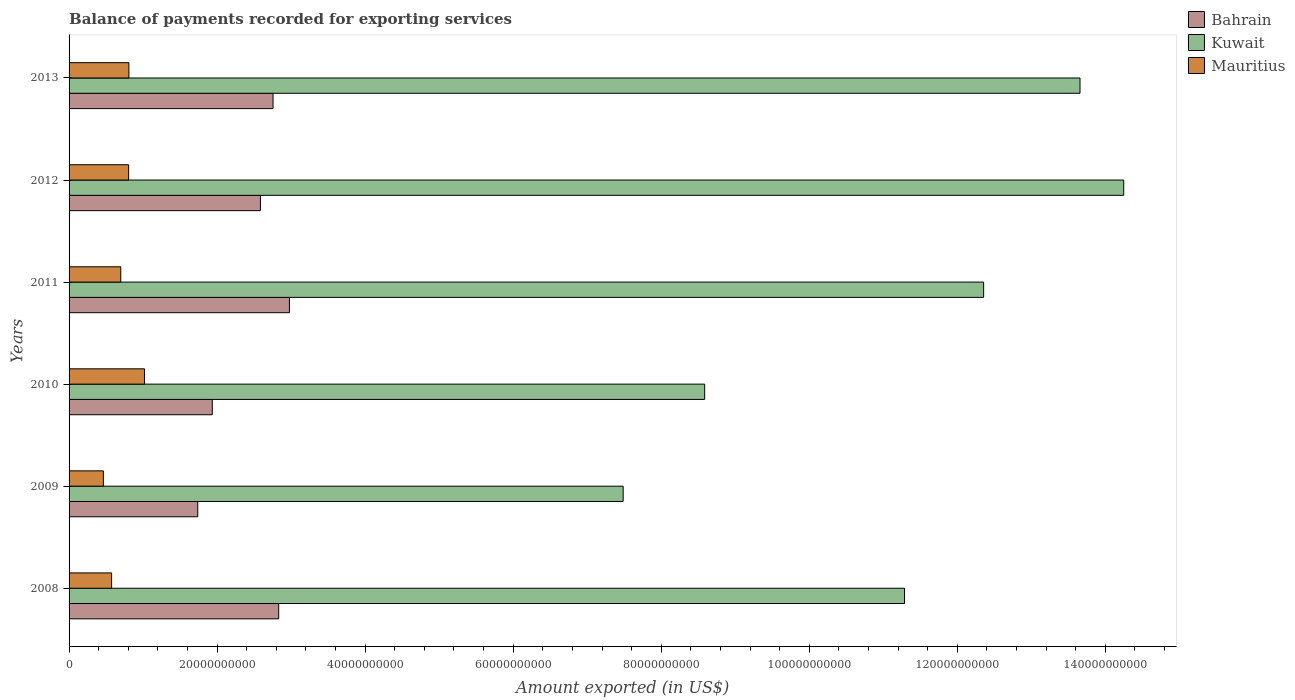How many groups of bars are there?
Keep it short and to the point. 6. How many bars are there on the 6th tick from the top?
Your answer should be very brief. 3. In how many cases, is the number of bars for a given year not equal to the number of legend labels?
Offer a very short reply. 0. What is the amount exported in Bahrain in 2008?
Your answer should be very brief. 2.83e+1. Across all years, what is the maximum amount exported in Bahrain?
Provide a short and direct response. 2.98e+1. Across all years, what is the minimum amount exported in Bahrain?
Ensure brevity in your answer.  1.74e+1. In which year was the amount exported in Kuwait maximum?
Your response must be concise. 2012. What is the total amount exported in Kuwait in the graph?
Make the answer very short. 6.76e+11. What is the difference between the amount exported in Mauritius in 2008 and that in 2013?
Provide a succinct answer. -2.33e+09. What is the difference between the amount exported in Kuwait in 2009 and the amount exported in Mauritius in 2011?
Your response must be concise. 6.79e+1. What is the average amount exported in Mauritius per year?
Offer a terse response. 7.28e+09. In the year 2010, what is the difference between the amount exported in Kuwait and amount exported in Bahrain?
Offer a very short reply. 6.65e+1. What is the ratio of the amount exported in Kuwait in 2008 to that in 2013?
Your response must be concise. 0.83. Is the difference between the amount exported in Kuwait in 2009 and 2010 greater than the difference between the amount exported in Bahrain in 2009 and 2010?
Keep it short and to the point. No. What is the difference between the highest and the second highest amount exported in Mauritius?
Ensure brevity in your answer.  2.11e+09. What is the difference between the highest and the lowest amount exported in Bahrain?
Keep it short and to the point. 1.24e+1. In how many years, is the amount exported in Mauritius greater than the average amount exported in Mauritius taken over all years?
Offer a terse response. 3. Is the sum of the amount exported in Bahrain in 2011 and 2013 greater than the maximum amount exported in Kuwait across all years?
Your answer should be very brief. No. What does the 3rd bar from the top in 2012 represents?
Keep it short and to the point. Bahrain. What does the 2nd bar from the bottom in 2012 represents?
Provide a short and direct response. Kuwait. How many bars are there?
Provide a short and direct response. 18. How many years are there in the graph?
Keep it short and to the point. 6. Are the values on the major ticks of X-axis written in scientific E-notation?
Ensure brevity in your answer.  No. Does the graph contain grids?
Give a very brief answer. No. How are the legend labels stacked?
Provide a short and direct response. Vertical. What is the title of the graph?
Provide a succinct answer. Balance of payments recorded for exporting services. Does "San Marino" appear as one of the legend labels in the graph?
Ensure brevity in your answer.  No. What is the label or title of the X-axis?
Provide a succinct answer. Amount exported (in US$). What is the label or title of the Y-axis?
Provide a short and direct response. Years. What is the Amount exported (in US$) in Bahrain in 2008?
Offer a terse response. 2.83e+1. What is the Amount exported (in US$) of Kuwait in 2008?
Your answer should be very brief. 1.13e+11. What is the Amount exported (in US$) in Mauritius in 2008?
Make the answer very short. 5.75e+09. What is the Amount exported (in US$) of Bahrain in 2009?
Give a very brief answer. 1.74e+1. What is the Amount exported (in US$) of Kuwait in 2009?
Offer a very short reply. 7.49e+1. What is the Amount exported (in US$) of Mauritius in 2009?
Ensure brevity in your answer.  4.64e+09. What is the Amount exported (in US$) in Bahrain in 2010?
Your answer should be compact. 1.93e+1. What is the Amount exported (in US$) in Kuwait in 2010?
Keep it short and to the point. 8.59e+1. What is the Amount exported (in US$) in Mauritius in 2010?
Your answer should be compact. 1.02e+1. What is the Amount exported (in US$) in Bahrain in 2011?
Give a very brief answer. 2.98e+1. What is the Amount exported (in US$) in Kuwait in 2011?
Your answer should be compact. 1.24e+11. What is the Amount exported (in US$) in Mauritius in 2011?
Keep it short and to the point. 6.98e+09. What is the Amount exported (in US$) of Bahrain in 2012?
Keep it short and to the point. 2.59e+1. What is the Amount exported (in US$) of Kuwait in 2012?
Your answer should be very brief. 1.42e+11. What is the Amount exported (in US$) of Mauritius in 2012?
Keep it short and to the point. 8.05e+09. What is the Amount exported (in US$) in Bahrain in 2013?
Offer a terse response. 2.76e+1. What is the Amount exported (in US$) in Kuwait in 2013?
Give a very brief answer. 1.37e+11. What is the Amount exported (in US$) of Mauritius in 2013?
Your answer should be very brief. 8.08e+09. Across all years, what is the maximum Amount exported (in US$) of Bahrain?
Provide a succinct answer. 2.98e+1. Across all years, what is the maximum Amount exported (in US$) of Kuwait?
Ensure brevity in your answer.  1.42e+11. Across all years, what is the maximum Amount exported (in US$) in Mauritius?
Provide a succinct answer. 1.02e+1. Across all years, what is the minimum Amount exported (in US$) of Bahrain?
Your response must be concise. 1.74e+1. Across all years, what is the minimum Amount exported (in US$) of Kuwait?
Your response must be concise. 7.49e+1. Across all years, what is the minimum Amount exported (in US$) of Mauritius?
Your response must be concise. 4.64e+09. What is the total Amount exported (in US$) of Bahrain in the graph?
Provide a short and direct response. 1.48e+11. What is the total Amount exported (in US$) of Kuwait in the graph?
Keep it short and to the point. 6.76e+11. What is the total Amount exported (in US$) in Mauritius in the graph?
Keep it short and to the point. 4.37e+1. What is the difference between the Amount exported (in US$) of Bahrain in 2008 and that in 2009?
Your answer should be very brief. 1.09e+1. What is the difference between the Amount exported (in US$) in Kuwait in 2008 and that in 2009?
Your response must be concise. 3.80e+1. What is the difference between the Amount exported (in US$) of Mauritius in 2008 and that in 2009?
Your answer should be very brief. 1.11e+09. What is the difference between the Amount exported (in US$) in Bahrain in 2008 and that in 2010?
Your response must be concise. 8.97e+09. What is the difference between the Amount exported (in US$) of Kuwait in 2008 and that in 2010?
Make the answer very short. 2.70e+1. What is the difference between the Amount exported (in US$) of Mauritius in 2008 and that in 2010?
Your response must be concise. -4.44e+09. What is the difference between the Amount exported (in US$) in Bahrain in 2008 and that in 2011?
Provide a succinct answer. -1.45e+09. What is the difference between the Amount exported (in US$) of Kuwait in 2008 and that in 2011?
Provide a succinct answer. -1.07e+1. What is the difference between the Amount exported (in US$) in Mauritius in 2008 and that in 2011?
Provide a short and direct response. -1.24e+09. What is the difference between the Amount exported (in US$) in Bahrain in 2008 and that in 2012?
Provide a short and direct response. 2.47e+09. What is the difference between the Amount exported (in US$) in Kuwait in 2008 and that in 2012?
Offer a very short reply. -2.96e+1. What is the difference between the Amount exported (in US$) in Mauritius in 2008 and that in 2012?
Offer a terse response. -2.30e+09. What is the difference between the Amount exported (in US$) in Bahrain in 2008 and that in 2013?
Offer a terse response. 7.64e+08. What is the difference between the Amount exported (in US$) in Kuwait in 2008 and that in 2013?
Keep it short and to the point. -2.37e+1. What is the difference between the Amount exported (in US$) of Mauritius in 2008 and that in 2013?
Ensure brevity in your answer.  -2.33e+09. What is the difference between the Amount exported (in US$) of Bahrain in 2009 and that in 2010?
Keep it short and to the point. -1.96e+09. What is the difference between the Amount exported (in US$) in Kuwait in 2009 and that in 2010?
Provide a succinct answer. -1.10e+1. What is the difference between the Amount exported (in US$) in Mauritius in 2009 and that in 2010?
Give a very brief answer. -5.55e+09. What is the difference between the Amount exported (in US$) of Bahrain in 2009 and that in 2011?
Make the answer very short. -1.24e+1. What is the difference between the Amount exported (in US$) of Kuwait in 2009 and that in 2011?
Make the answer very short. -4.87e+1. What is the difference between the Amount exported (in US$) of Mauritius in 2009 and that in 2011?
Keep it short and to the point. -2.35e+09. What is the difference between the Amount exported (in US$) in Bahrain in 2009 and that in 2012?
Your answer should be compact. -8.47e+09. What is the difference between the Amount exported (in US$) in Kuwait in 2009 and that in 2012?
Ensure brevity in your answer.  -6.76e+1. What is the difference between the Amount exported (in US$) in Mauritius in 2009 and that in 2012?
Provide a short and direct response. -3.41e+09. What is the difference between the Amount exported (in US$) of Bahrain in 2009 and that in 2013?
Your answer should be very brief. -1.02e+1. What is the difference between the Amount exported (in US$) in Kuwait in 2009 and that in 2013?
Provide a succinct answer. -6.17e+1. What is the difference between the Amount exported (in US$) of Mauritius in 2009 and that in 2013?
Provide a short and direct response. -3.45e+09. What is the difference between the Amount exported (in US$) in Bahrain in 2010 and that in 2011?
Give a very brief answer. -1.04e+1. What is the difference between the Amount exported (in US$) in Kuwait in 2010 and that in 2011?
Provide a succinct answer. -3.77e+1. What is the difference between the Amount exported (in US$) in Mauritius in 2010 and that in 2011?
Provide a succinct answer. 3.21e+09. What is the difference between the Amount exported (in US$) in Bahrain in 2010 and that in 2012?
Make the answer very short. -6.50e+09. What is the difference between the Amount exported (in US$) of Kuwait in 2010 and that in 2012?
Your response must be concise. -5.66e+1. What is the difference between the Amount exported (in US$) of Mauritius in 2010 and that in 2012?
Keep it short and to the point. 2.14e+09. What is the difference between the Amount exported (in US$) of Bahrain in 2010 and that in 2013?
Offer a very short reply. -8.21e+09. What is the difference between the Amount exported (in US$) of Kuwait in 2010 and that in 2013?
Give a very brief answer. -5.07e+1. What is the difference between the Amount exported (in US$) in Mauritius in 2010 and that in 2013?
Your answer should be very brief. 2.11e+09. What is the difference between the Amount exported (in US$) of Bahrain in 2011 and that in 2012?
Ensure brevity in your answer.  3.92e+09. What is the difference between the Amount exported (in US$) in Kuwait in 2011 and that in 2012?
Give a very brief answer. -1.89e+1. What is the difference between the Amount exported (in US$) of Mauritius in 2011 and that in 2012?
Provide a succinct answer. -1.06e+09. What is the difference between the Amount exported (in US$) of Bahrain in 2011 and that in 2013?
Make the answer very short. 2.21e+09. What is the difference between the Amount exported (in US$) in Kuwait in 2011 and that in 2013?
Make the answer very short. -1.30e+1. What is the difference between the Amount exported (in US$) in Mauritius in 2011 and that in 2013?
Make the answer very short. -1.10e+09. What is the difference between the Amount exported (in US$) of Bahrain in 2012 and that in 2013?
Keep it short and to the point. -1.70e+09. What is the difference between the Amount exported (in US$) of Kuwait in 2012 and that in 2013?
Make the answer very short. 5.90e+09. What is the difference between the Amount exported (in US$) in Mauritius in 2012 and that in 2013?
Ensure brevity in your answer.  -3.39e+07. What is the difference between the Amount exported (in US$) of Bahrain in 2008 and the Amount exported (in US$) of Kuwait in 2009?
Give a very brief answer. -4.65e+1. What is the difference between the Amount exported (in US$) in Bahrain in 2008 and the Amount exported (in US$) in Mauritius in 2009?
Offer a very short reply. 2.37e+1. What is the difference between the Amount exported (in US$) in Kuwait in 2008 and the Amount exported (in US$) in Mauritius in 2009?
Offer a terse response. 1.08e+11. What is the difference between the Amount exported (in US$) in Bahrain in 2008 and the Amount exported (in US$) in Kuwait in 2010?
Keep it short and to the point. -5.75e+1. What is the difference between the Amount exported (in US$) in Bahrain in 2008 and the Amount exported (in US$) in Mauritius in 2010?
Your response must be concise. 1.81e+1. What is the difference between the Amount exported (in US$) of Kuwait in 2008 and the Amount exported (in US$) of Mauritius in 2010?
Provide a short and direct response. 1.03e+11. What is the difference between the Amount exported (in US$) of Bahrain in 2008 and the Amount exported (in US$) of Kuwait in 2011?
Ensure brevity in your answer.  -9.52e+1. What is the difference between the Amount exported (in US$) in Bahrain in 2008 and the Amount exported (in US$) in Mauritius in 2011?
Provide a short and direct response. 2.13e+1. What is the difference between the Amount exported (in US$) in Kuwait in 2008 and the Amount exported (in US$) in Mauritius in 2011?
Provide a short and direct response. 1.06e+11. What is the difference between the Amount exported (in US$) in Bahrain in 2008 and the Amount exported (in US$) in Kuwait in 2012?
Make the answer very short. -1.14e+11. What is the difference between the Amount exported (in US$) of Bahrain in 2008 and the Amount exported (in US$) of Mauritius in 2012?
Your answer should be very brief. 2.03e+1. What is the difference between the Amount exported (in US$) in Kuwait in 2008 and the Amount exported (in US$) in Mauritius in 2012?
Ensure brevity in your answer.  1.05e+11. What is the difference between the Amount exported (in US$) in Bahrain in 2008 and the Amount exported (in US$) in Kuwait in 2013?
Give a very brief answer. -1.08e+11. What is the difference between the Amount exported (in US$) of Bahrain in 2008 and the Amount exported (in US$) of Mauritius in 2013?
Provide a succinct answer. 2.02e+1. What is the difference between the Amount exported (in US$) of Kuwait in 2008 and the Amount exported (in US$) of Mauritius in 2013?
Your answer should be very brief. 1.05e+11. What is the difference between the Amount exported (in US$) of Bahrain in 2009 and the Amount exported (in US$) of Kuwait in 2010?
Your answer should be very brief. -6.85e+1. What is the difference between the Amount exported (in US$) of Bahrain in 2009 and the Amount exported (in US$) of Mauritius in 2010?
Give a very brief answer. 7.20e+09. What is the difference between the Amount exported (in US$) of Kuwait in 2009 and the Amount exported (in US$) of Mauritius in 2010?
Ensure brevity in your answer.  6.47e+1. What is the difference between the Amount exported (in US$) of Bahrain in 2009 and the Amount exported (in US$) of Kuwait in 2011?
Your response must be concise. -1.06e+11. What is the difference between the Amount exported (in US$) of Bahrain in 2009 and the Amount exported (in US$) of Mauritius in 2011?
Give a very brief answer. 1.04e+1. What is the difference between the Amount exported (in US$) of Kuwait in 2009 and the Amount exported (in US$) of Mauritius in 2011?
Offer a terse response. 6.79e+1. What is the difference between the Amount exported (in US$) of Bahrain in 2009 and the Amount exported (in US$) of Kuwait in 2012?
Keep it short and to the point. -1.25e+11. What is the difference between the Amount exported (in US$) in Bahrain in 2009 and the Amount exported (in US$) in Mauritius in 2012?
Provide a short and direct response. 9.34e+09. What is the difference between the Amount exported (in US$) of Kuwait in 2009 and the Amount exported (in US$) of Mauritius in 2012?
Provide a succinct answer. 6.68e+1. What is the difference between the Amount exported (in US$) in Bahrain in 2009 and the Amount exported (in US$) in Kuwait in 2013?
Your response must be concise. -1.19e+11. What is the difference between the Amount exported (in US$) of Bahrain in 2009 and the Amount exported (in US$) of Mauritius in 2013?
Your answer should be very brief. 9.30e+09. What is the difference between the Amount exported (in US$) of Kuwait in 2009 and the Amount exported (in US$) of Mauritius in 2013?
Your answer should be very brief. 6.68e+1. What is the difference between the Amount exported (in US$) of Bahrain in 2010 and the Amount exported (in US$) of Kuwait in 2011?
Provide a short and direct response. -1.04e+11. What is the difference between the Amount exported (in US$) in Bahrain in 2010 and the Amount exported (in US$) in Mauritius in 2011?
Provide a succinct answer. 1.24e+1. What is the difference between the Amount exported (in US$) of Kuwait in 2010 and the Amount exported (in US$) of Mauritius in 2011?
Keep it short and to the point. 7.89e+1. What is the difference between the Amount exported (in US$) in Bahrain in 2010 and the Amount exported (in US$) in Kuwait in 2012?
Make the answer very short. -1.23e+11. What is the difference between the Amount exported (in US$) of Bahrain in 2010 and the Amount exported (in US$) of Mauritius in 2012?
Offer a very short reply. 1.13e+1. What is the difference between the Amount exported (in US$) in Kuwait in 2010 and the Amount exported (in US$) in Mauritius in 2012?
Provide a short and direct response. 7.78e+1. What is the difference between the Amount exported (in US$) of Bahrain in 2010 and the Amount exported (in US$) of Kuwait in 2013?
Your response must be concise. -1.17e+11. What is the difference between the Amount exported (in US$) of Bahrain in 2010 and the Amount exported (in US$) of Mauritius in 2013?
Your response must be concise. 1.13e+1. What is the difference between the Amount exported (in US$) in Kuwait in 2010 and the Amount exported (in US$) in Mauritius in 2013?
Your answer should be very brief. 7.78e+1. What is the difference between the Amount exported (in US$) in Bahrain in 2011 and the Amount exported (in US$) in Kuwait in 2012?
Give a very brief answer. -1.13e+11. What is the difference between the Amount exported (in US$) of Bahrain in 2011 and the Amount exported (in US$) of Mauritius in 2012?
Offer a terse response. 2.17e+1. What is the difference between the Amount exported (in US$) in Kuwait in 2011 and the Amount exported (in US$) in Mauritius in 2012?
Your answer should be very brief. 1.16e+11. What is the difference between the Amount exported (in US$) of Bahrain in 2011 and the Amount exported (in US$) of Kuwait in 2013?
Your answer should be very brief. -1.07e+11. What is the difference between the Amount exported (in US$) in Bahrain in 2011 and the Amount exported (in US$) in Mauritius in 2013?
Offer a very short reply. 2.17e+1. What is the difference between the Amount exported (in US$) in Kuwait in 2011 and the Amount exported (in US$) in Mauritius in 2013?
Offer a very short reply. 1.15e+11. What is the difference between the Amount exported (in US$) of Bahrain in 2012 and the Amount exported (in US$) of Kuwait in 2013?
Offer a terse response. -1.11e+11. What is the difference between the Amount exported (in US$) of Bahrain in 2012 and the Amount exported (in US$) of Mauritius in 2013?
Provide a short and direct response. 1.78e+1. What is the difference between the Amount exported (in US$) of Kuwait in 2012 and the Amount exported (in US$) of Mauritius in 2013?
Offer a very short reply. 1.34e+11. What is the average Amount exported (in US$) in Bahrain per year?
Your answer should be very brief. 2.47e+1. What is the average Amount exported (in US$) of Kuwait per year?
Your answer should be very brief. 1.13e+11. What is the average Amount exported (in US$) of Mauritius per year?
Keep it short and to the point. 7.28e+09. In the year 2008, what is the difference between the Amount exported (in US$) in Bahrain and Amount exported (in US$) in Kuwait?
Make the answer very short. -8.45e+1. In the year 2008, what is the difference between the Amount exported (in US$) of Bahrain and Amount exported (in US$) of Mauritius?
Ensure brevity in your answer.  2.26e+1. In the year 2008, what is the difference between the Amount exported (in US$) of Kuwait and Amount exported (in US$) of Mauritius?
Make the answer very short. 1.07e+11. In the year 2009, what is the difference between the Amount exported (in US$) in Bahrain and Amount exported (in US$) in Kuwait?
Give a very brief answer. -5.75e+1. In the year 2009, what is the difference between the Amount exported (in US$) in Bahrain and Amount exported (in US$) in Mauritius?
Make the answer very short. 1.27e+1. In the year 2009, what is the difference between the Amount exported (in US$) in Kuwait and Amount exported (in US$) in Mauritius?
Ensure brevity in your answer.  7.02e+1. In the year 2010, what is the difference between the Amount exported (in US$) of Bahrain and Amount exported (in US$) of Kuwait?
Make the answer very short. -6.65e+1. In the year 2010, what is the difference between the Amount exported (in US$) of Bahrain and Amount exported (in US$) of Mauritius?
Offer a terse response. 9.16e+09. In the year 2010, what is the difference between the Amount exported (in US$) of Kuwait and Amount exported (in US$) of Mauritius?
Make the answer very short. 7.57e+1. In the year 2011, what is the difference between the Amount exported (in US$) in Bahrain and Amount exported (in US$) in Kuwait?
Offer a terse response. -9.38e+1. In the year 2011, what is the difference between the Amount exported (in US$) in Bahrain and Amount exported (in US$) in Mauritius?
Make the answer very short. 2.28e+1. In the year 2011, what is the difference between the Amount exported (in US$) in Kuwait and Amount exported (in US$) in Mauritius?
Give a very brief answer. 1.17e+11. In the year 2012, what is the difference between the Amount exported (in US$) in Bahrain and Amount exported (in US$) in Kuwait?
Ensure brevity in your answer.  -1.17e+11. In the year 2012, what is the difference between the Amount exported (in US$) in Bahrain and Amount exported (in US$) in Mauritius?
Your response must be concise. 1.78e+1. In the year 2012, what is the difference between the Amount exported (in US$) of Kuwait and Amount exported (in US$) of Mauritius?
Ensure brevity in your answer.  1.34e+11. In the year 2013, what is the difference between the Amount exported (in US$) in Bahrain and Amount exported (in US$) in Kuwait?
Make the answer very short. -1.09e+11. In the year 2013, what is the difference between the Amount exported (in US$) of Bahrain and Amount exported (in US$) of Mauritius?
Keep it short and to the point. 1.95e+1. In the year 2013, what is the difference between the Amount exported (in US$) in Kuwait and Amount exported (in US$) in Mauritius?
Make the answer very short. 1.28e+11. What is the ratio of the Amount exported (in US$) in Bahrain in 2008 to that in 2009?
Ensure brevity in your answer.  1.63. What is the ratio of the Amount exported (in US$) of Kuwait in 2008 to that in 2009?
Offer a very short reply. 1.51. What is the ratio of the Amount exported (in US$) of Mauritius in 2008 to that in 2009?
Keep it short and to the point. 1.24. What is the ratio of the Amount exported (in US$) in Bahrain in 2008 to that in 2010?
Your response must be concise. 1.46. What is the ratio of the Amount exported (in US$) in Kuwait in 2008 to that in 2010?
Provide a short and direct response. 1.31. What is the ratio of the Amount exported (in US$) in Mauritius in 2008 to that in 2010?
Your answer should be very brief. 0.56. What is the ratio of the Amount exported (in US$) in Bahrain in 2008 to that in 2011?
Provide a short and direct response. 0.95. What is the ratio of the Amount exported (in US$) of Kuwait in 2008 to that in 2011?
Ensure brevity in your answer.  0.91. What is the ratio of the Amount exported (in US$) of Mauritius in 2008 to that in 2011?
Make the answer very short. 0.82. What is the ratio of the Amount exported (in US$) in Bahrain in 2008 to that in 2012?
Ensure brevity in your answer.  1.1. What is the ratio of the Amount exported (in US$) of Kuwait in 2008 to that in 2012?
Offer a terse response. 0.79. What is the ratio of the Amount exported (in US$) in Mauritius in 2008 to that in 2012?
Make the answer very short. 0.71. What is the ratio of the Amount exported (in US$) in Bahrain in 2008 to that in 2013?
Your answer should be very brief. 1.03. What is the ratio of the Amount exported (in US$) of Kuwait in 2008 to that in 2013?
Give a very brief answer. 0.83. What is the ratio of the Amount exported (in US$) in Mauritius in 2008 to that in 2013?
Your answer should be very brief. 0.71. What is the ratio of the Amount exported (in US$) of Bahrain in 2009 to that in 2010?
Give a very brief answer. 0.9. What is the ratio of the Amount exported (in US$) in Kuwait in 2009 to that in 2010?
Offer a very short reply. 0.87. What is the ratio of the Amount exported (in US$) in Mauritius in 2009 to that in 2010?
Offer a very short reply. 0.45. What is the ratio of the Amount exported (in US$) in Bahrain in 2009 to that in 2011?
Provide a short and direct response. 0.58. What is the ratio of the Amount exported (in US$) of Kuwait in 2009 to that in 2011?
Offer a very short reply. 0.61. What is the ratio of the Amount exported (in US$) of Mauritius in 2009 to that in 2011?
Offer a terse response. 0.66. What is the ratio of the Amount exported (in US$) in Bahrain in 2009 to that in 2012?
Your response must be concise. 0.67. What is the ratio of the Amount exported (in US$) in Kuwait in 2009 to that in 2012?
Keep it short and to the point. 0.53. What is the ratio of the Amount exported (in US$) in Mauritius in 2009 to that in 2012?
Provide a short and direct response. 0.58. What is the ratio of the Amount exported (in US$) in Bahrain in 2009 to that in 2013?
Provide a succinct answer. 0.63. What is the ratio of the Amount exported (in US$) of Kuwait in 2009 to that in 2013?
Your answer should be very brief. 0.55. What is the ratio of the Amount exported (in US$) of Mauritius in 2009 to that in 2013?
Your answer should be very brief. 0.57. What is the ratio of the Amount exported (in US$) in Bahrain in 2010 to that in 2011?
Ensure brevity in your answer.  0.65. What is the ratio of the Amount exported (in US$) in Kuwait in 2010 to that in 2011?
Give a very brief answer. 0.69. What is the ratio of the Amount exported (in US$) of Mauritius in 2010 to that in 2011?
Offer a very short reply. 1.46. What is the ratio of the Amount exported (in US$) in Bahrain in 2010 to that in 2012?
Provide a succinct answer. 0.75. What is the ratio of the Amount exported (in US$) of Kuwait in 2010 to that in 2012?
Provide a short and direct response. 0.6. What is the ratio of the Amount exported (in US$) of Mauritius in 2010 to that in 2012?
Your answer should be compact. 1.27. What is the ratio of the Amount exported (in US$) of Bahrain in 2010 to that in 2013?
Offer a very short reply. 0.7. What is the ratio of the Amount exported (in US$) of Kuwait in 2010 to that in 2013?
Provide a short and direct response. 0.63. What is the ratio of the Amount exported (in US$) of Mauritius in 2010 to that in 2013?
Your answer should be compact. 1.26. What is the ratio of the Amount exported (in US$) in Bahrain in 2011 to that in 2012?
Provide a succinct answer. 1.15. What is the ratio of the Amount exported (in US$) of Kuwait in 2011 to that in 2012?
Offer a very short reply. 0.87. What is the ratio of the Amount exported (in US$) in Mauritius in 2011 to that in 2012?
Provide a succinct answer. 0.87. What is the ratio of the Amount exported (in US$) in Bahrain in 2011 to that in 2013?
Offer a very short reply. 1.08. What is the ratio of the Amount exported (in US$) in Kuwait in 2011 to that in 2013?
Provide a succinct answer. 0.9. What is the ratio of the Amount exported (in US$) in Mauritius in 2011 to that in 2013?
Give a very brief answer. 0.86. What is the ratio of the Amount exported (in US$) in Bahrain in 2012 to that in 2013?
Provide a succinct answer. 0.94. What is the ratio of the Amount exported (in US$) in Kuwait in 2012 to that in 2013?
Your answer should be very brief. 1.04. What is the ratio of the Amount exported (in US$) of Mauritius in 2012 to that in 2013?
Provide a short and direct response. 1. What is the difference between the highest and the second highest Amount exported (in US$) in Bahrain?
Your answer should be compact. 1.45e+09. What is the difference between the highest and the second highest Amount exported (in US$) in Kuwait?
Provide a short and direct response. 5.90e+09. What is the difference between the highest and the second highest Amount exported (in US$) of Mauritius?
Provide a succinct answer. 2.11e+09. What is the difference between the highest and the lowest Amount exported (in US$) of Bahrain?
Your response must be concise. 1.24e+1. What is the difference between the highest and the lowest Amount exported (in US$) of Kuwait?
Offer a terse response. 6.76e+1. What is the difference between the highest and the lowest Amount exported (in US$) of Mauritius?
Offer a terse response. 5.55e+09. 